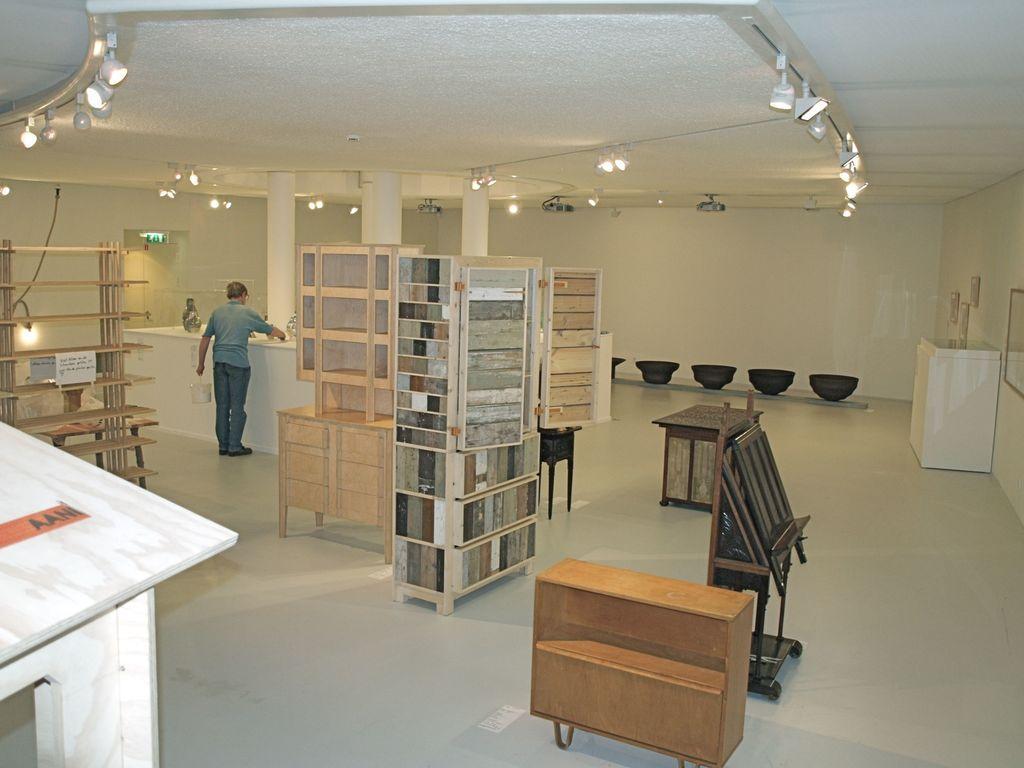How would you summarize this image in a sentence or two? In the image there is a man standing in front of a table. On table we can see some glass items and right side of the image there is a wall,mirror and middle there is a shelf, on top there is a roof. 